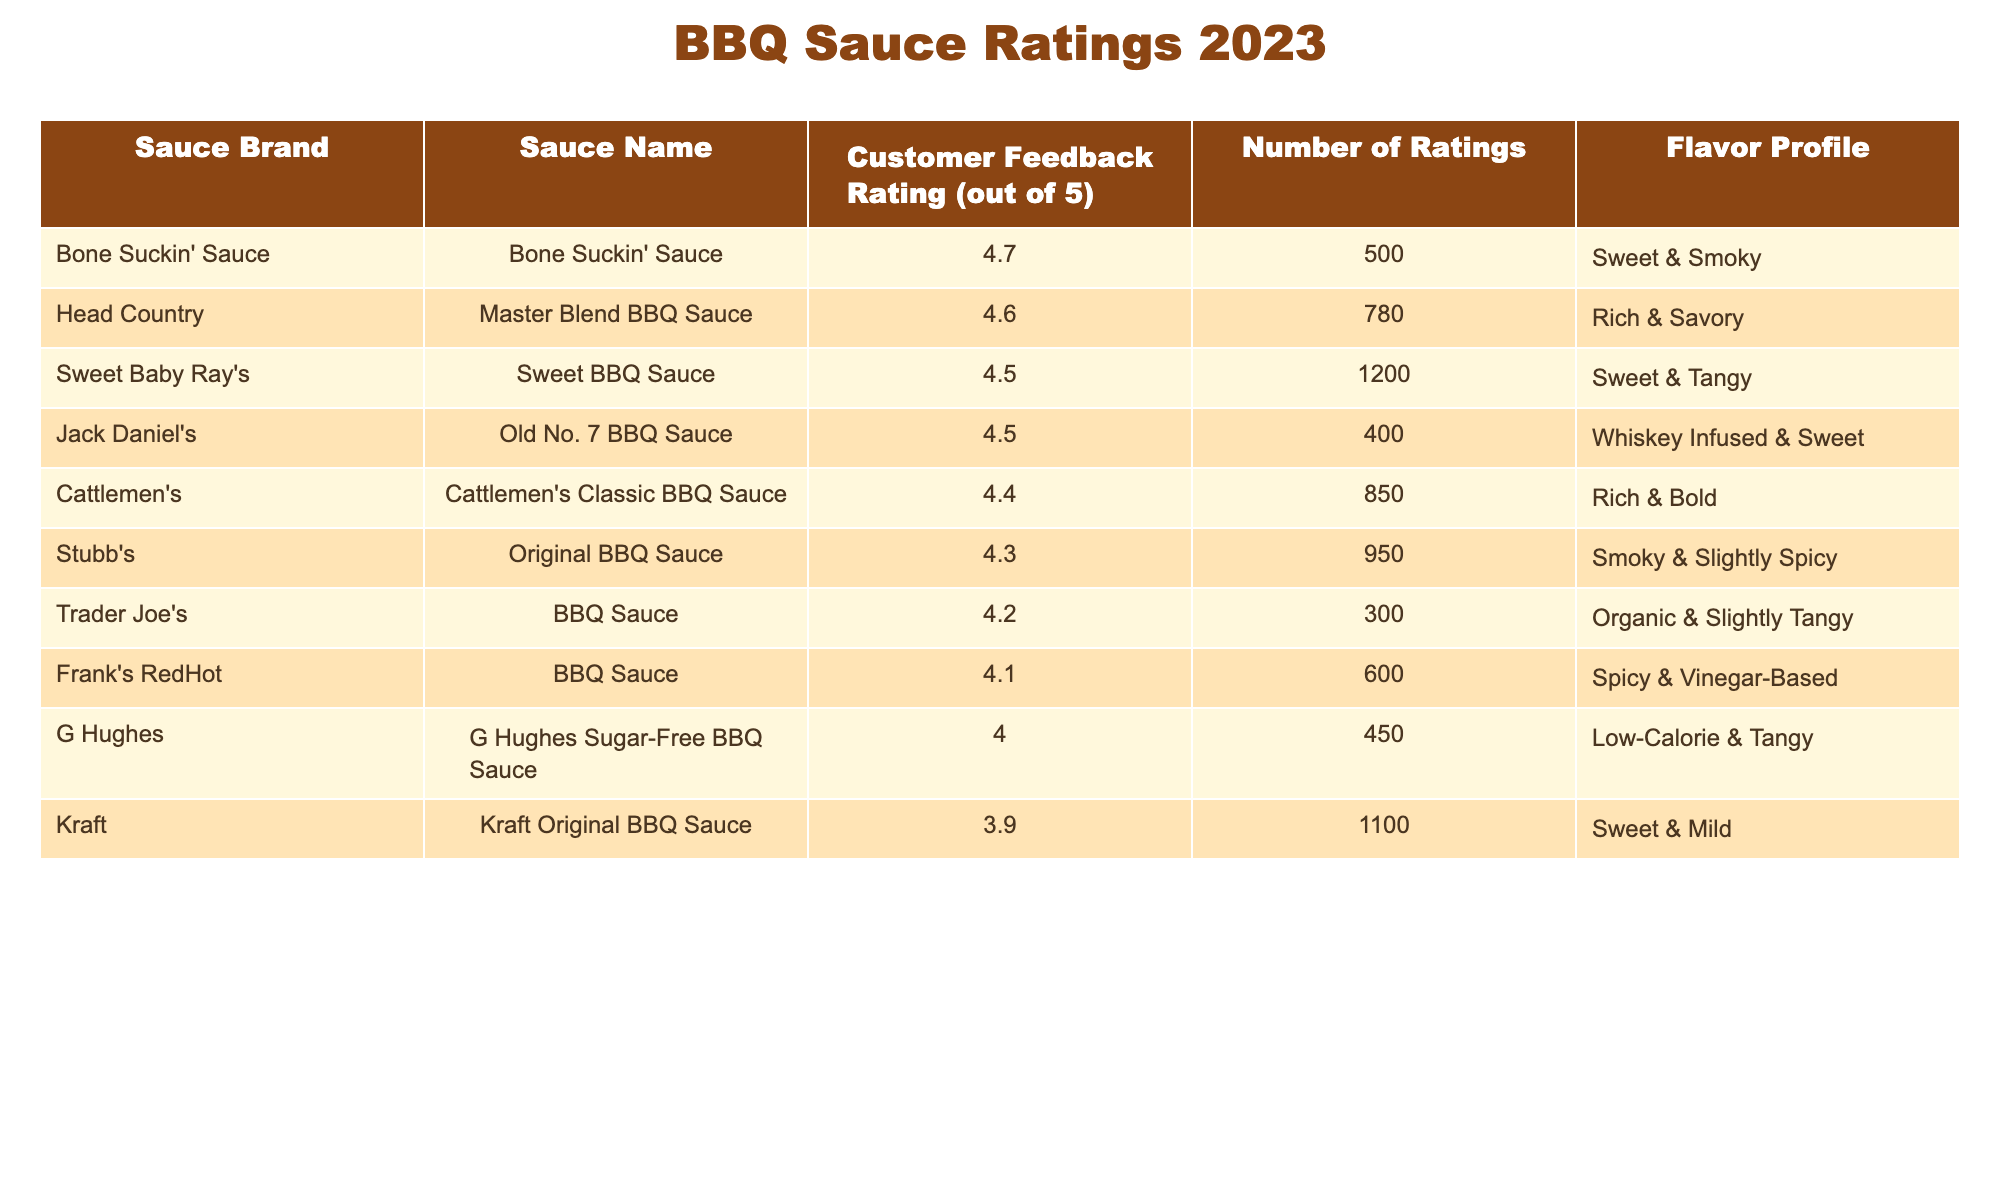What is the highest customer feedback rating for a BBQ sauce? The table shows the customer feedback ratings for various BBQ sauces. The highest customer feedback rating listed is 4.7 for Bone Suckin' Sauce.
Answer: 4.7 Which BBQ sauce has the lowest customer feedback rating? From the table, Kraft Original BBQ Sauce has the lowest customer feedback rating of 3.9 among the listed sauces.
Answer: 3.9 How many ratings did Jack Daniel's Old No. 7 BBQ Sauce receive? The table indicates that Jack Daniel's Old No. 7 BBQ Sauce received a total of 400 ratings.
Answer: 400 What is the average customer feedback rating for the sauces with a flavor profile of 'Sweet'? We consider the sauces with 'Sweet' as part of the flavor profile: Sweet Baby Ray's (4.5), Kraft Original BBQ Sauce (3.9), and Jack Daniel's Old No. 7 BBQ Sauce (4.5). The average rating calculation is (4.5 + 3.9 + 4.5) / 3 = 4.3.
Answer: 4.3 Is the number of ratings for Cattlemen's Classic BBQ Sauce greater than 800? The table shows that Cattlemen's Classic BBQ Sauce received 850 ratings, which is indeed greater than 800.
Answer: Yes Which sauce has a customer feedback rating closest to 4.4? The ratings closest to 4.4 in the table are Stubb's Original BBQ Sauce with a rating of 4.3 and Cattlemen's Classic BBQ Sauce with a rating of 4.4. Thus, the sauces that have a rating close to 4.4 are Cattlemen's (exactly 4.4) and Stubb's (just 0.1 lower).
Answer: Cattlemen's Classic BBQ Sauce What is the total number of ratings for all BBQ sauces listed in the table? By summing the number of ratings from each sauce: 1200 + 950 + 780 + 600 + 1100 + 850 + 500 + 300 + 400 + 450 = 5,780.
Answer: 5780 Which BBQ sauce has a rich flavor profile and what is its customer feedback rating? The table specifies Cattlemen's Classic BBQ Sauce and Head Country Master Blend BBQ Sauce as having a rich flavor profile. Their ratings are 4.4 and 4.6, respectively. Therefore, the sauces with rich flavor profiles are Cattlemen's (4.4) and Head Country (4.6).
Answer: Cattlemen's Classic BBQ Sauce (4.4) and Head Country (4.6) Are there any BBQ sauces with customer feedback ratings of 4.5 or higher? Yes, the BBQ sauces with ratings of 4.5 or higher listed in the table are Sweet Baby Ray's (4.5), Head Country (4.6), Bone Suckin' Sauce (4.7), and Jack Daniel's (4.5).
Answer: Yes 